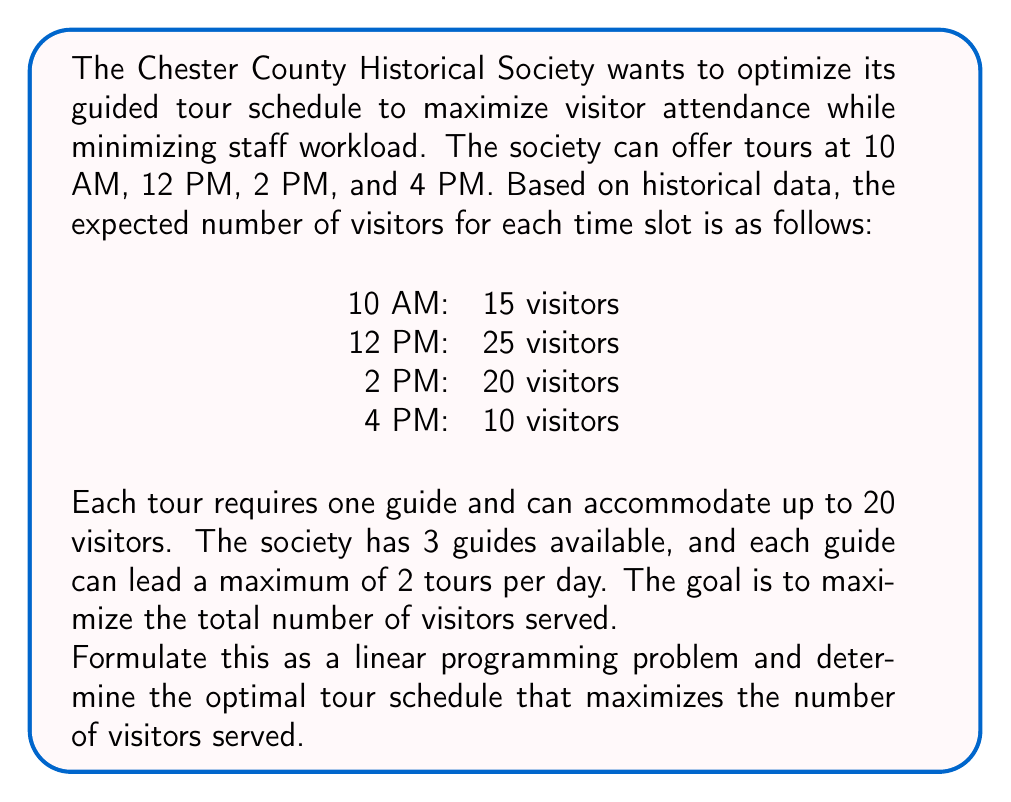Give your solution to this math problem. Let's approach this step-by-step:

1. Define decision variables:
   Let $x_i$ be the number of tours scheduled at time slot $i$, where $i = 1, 2, 3, 4$ corresponds to 10 AM, 12 PM, 2 PM, and 4 PM respectively.

2. Objective function:
   We want to maximize the total number of visitors served. This can be expressed as:
   $$\text{Maximize } Z = 15x_1 + 25x_2 + 20x_3 + 10x_4$$

3. Constraints:
   a. Number of tours at each time slot cannot exceed 1 (as we have one time slot):
      $x_1 \leq 1, x_2 \leq 1, x_3 \leq 1, x_4 \leq 1$

   b. Total number of tours cannot exceed 6 (3 guides × 2 tours max per guide):
      $x_1 + x_2 + x_3 + x_4 \leq 6$

   c. Non-negativity and integer constraints:
      $x_1, x_2, x_3, x_4 \geq 0$ and integer

4. Solving the linear programming problem:
   Given the small scale of this problem, we can solve it by inspection:
   - We should definitely schedule a tour at 12 PM (25 visitors) and 2 PM (20 visitors).
   - The next best option is 10 AM (15 visitors).
   - The 4 PM slot (10 visitors) is not as beneficial, so we can skip it.

5. Optimal solution:
   $x_1 = 1, x_2 = 1, x_3 = 1, x_4 = 0$

6. Maximum number of visitors served:
   $Z = 15(1) + 25(1) + 20(1) + 10(0) = 60$ visitors
Answer: The optimal tour schedule is to offer tours at 10 AM, 12 PM, and 2 PM. This schedule will serve a maximum of 60 visitors. 